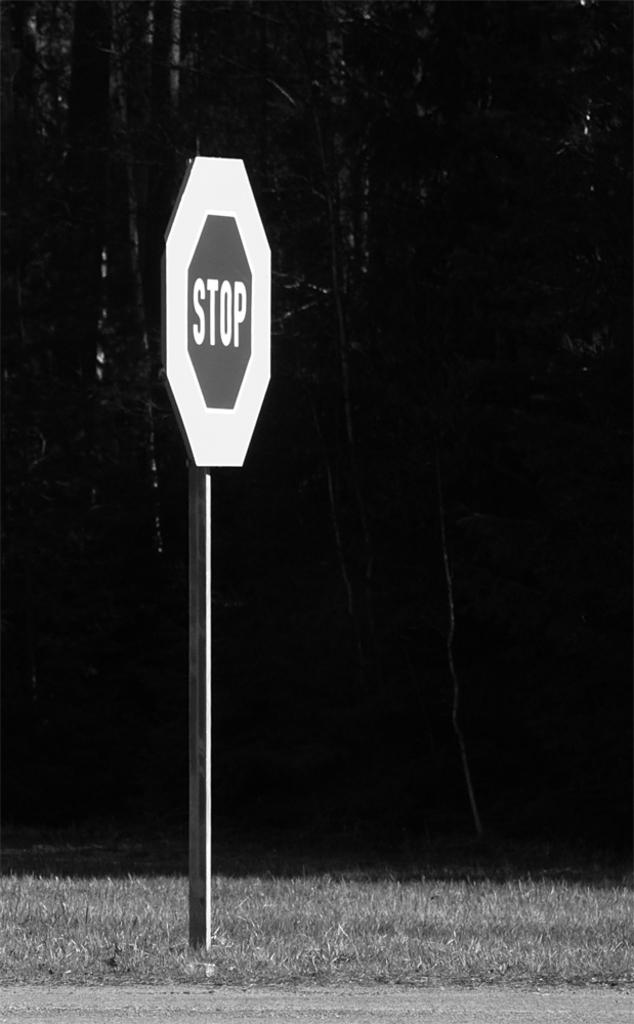Provide a one-sentence caption for the provided image. A stop sign with larger than usual border is stuck in the ground next to a road. 